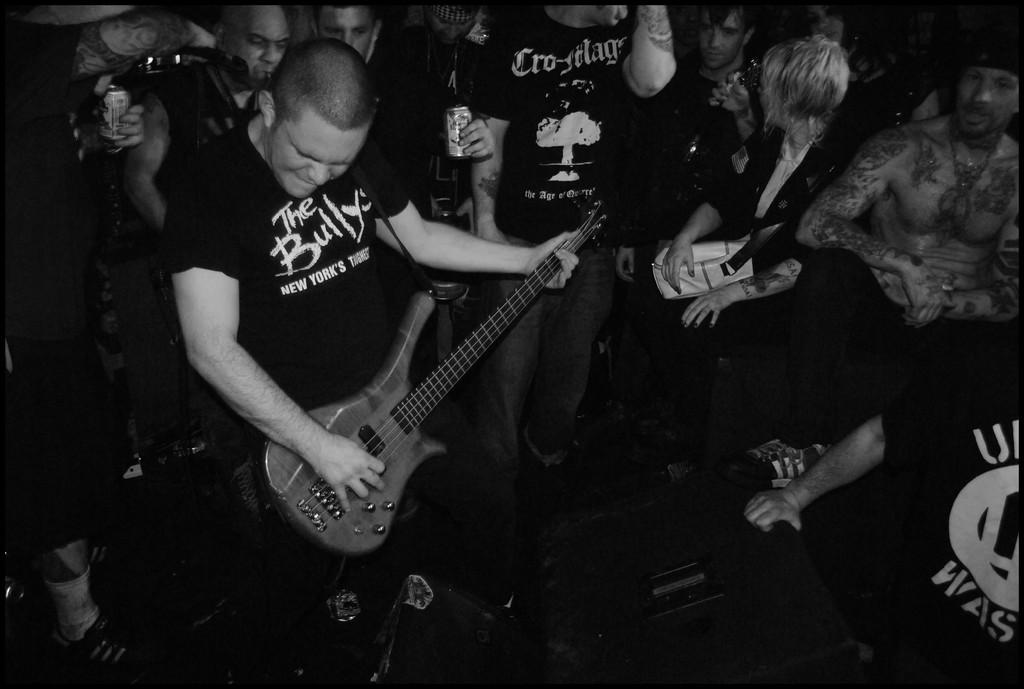What is happening in the image? There is a group of people in the image, and a man is standing and playing a guitar on the left side. Can you describe any objects in the image? Yes, there is a speaker visible in the bottom of the image. How many carts are being pushed by the people in the image? There are no carts present in the image; it features a group of people and a man playing a guitar. What type of breath is the guitar player taking in the image? The image does not show the guitar player's breath, so it cannot be determined from the image. 